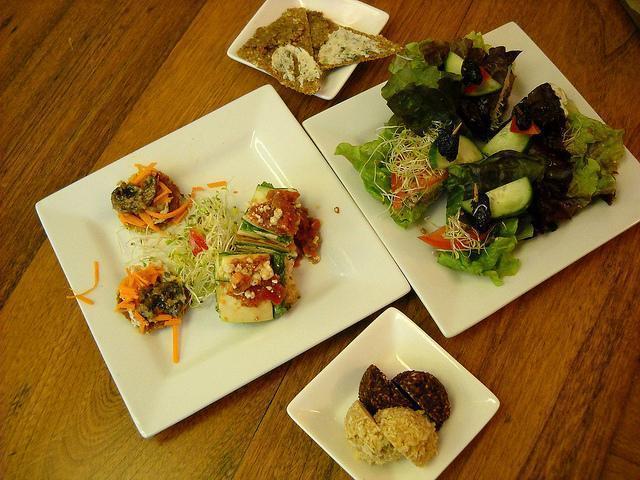How many plates of food?
Give a very brief answer. 4. 